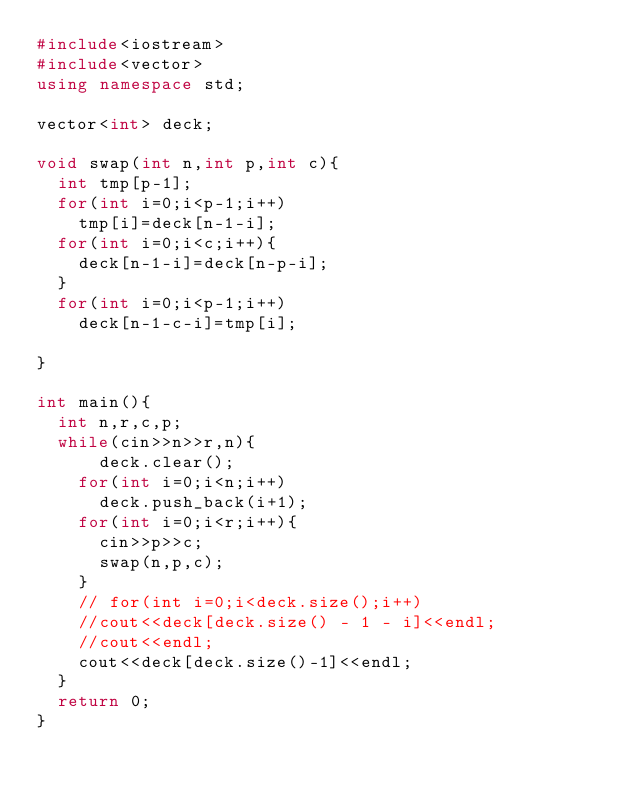<code> <loc_0><loc_0><loc_500><loc_500><_C++_>#include<iostream>
#include<vector>
using namespace std;

vector<int> deck;

void swap(int n,int p,int c){
  int tmp[p-1];
  for(int i=0;i<p-1;i++)
    tmp[i]=deck[n-1-i];
  for(int i=0;i<c;i++){
    deck[n-1-i]=deck[n-p-i];
  }
  for(int i=0;i<p-1;i++)
    deck[n-1-c-i]=tmp[i];

}

int main(){
  int n,r,c,p;
  while(cin>>n>>r,n){
      deck.clear();
    for(int i=0;i<n;i++)
      deck.push_back(i+1);
    for(int i=0;i<r;i++){
      cin>>p>>c;
      swap(n,p,c);
    }
    // for(int i=0;i<deck.size();i++)
    //cout<<deck[deck.size() - 1 - i]<<endl;
    //cout<<endl;
    cout<<deck[deck.size()-1]<<endl;
  }
  return 0;
}</code> 